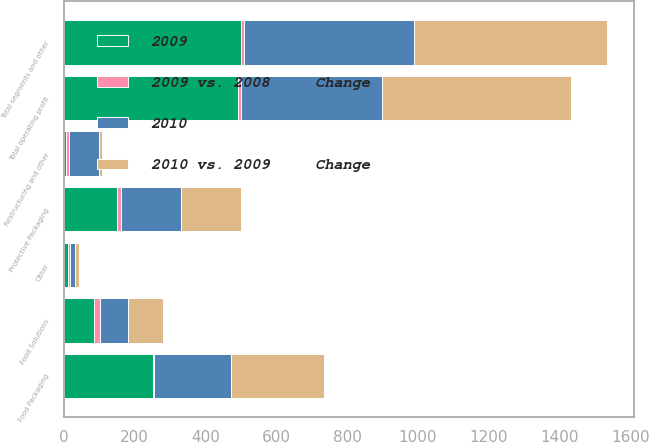Convert chart to OTSL. <chart><loc_0><loc_0><loc_500><loc_500><stacked_bar_chart><ecel><fcel>Food Packaging<fcel>Food Solutions<fcel>Protective Packaging<fcel>Other<fcel>Total segments and other<fcel>Restructuring and other<fcel>Total operating profit<nl><fcel>2010 vs. 2009     Change<fcel>262.7<fcel>99.2<fcel>169.5<fcel>11.2<fcel>542.6<fcel>7.6<fcel>535<nl><fcel>2009<fcel>251.7<fcel>85.7<fcel>150<fcel>11.9<fcel>499.3<fcel>7<fcel>492.3<nl><fcel>2010<fcel>217.5<fcel>80<fcel>169.1<fcel>15<fcel>481.6<fcel>85.1<fcel>396.5<nl><fcel>2009 vs. 2008     Change<fcel>4<fcel>16<fcel>13<fcel>6<fcel>9<fcel>9<fcel>9<nl></chart> 